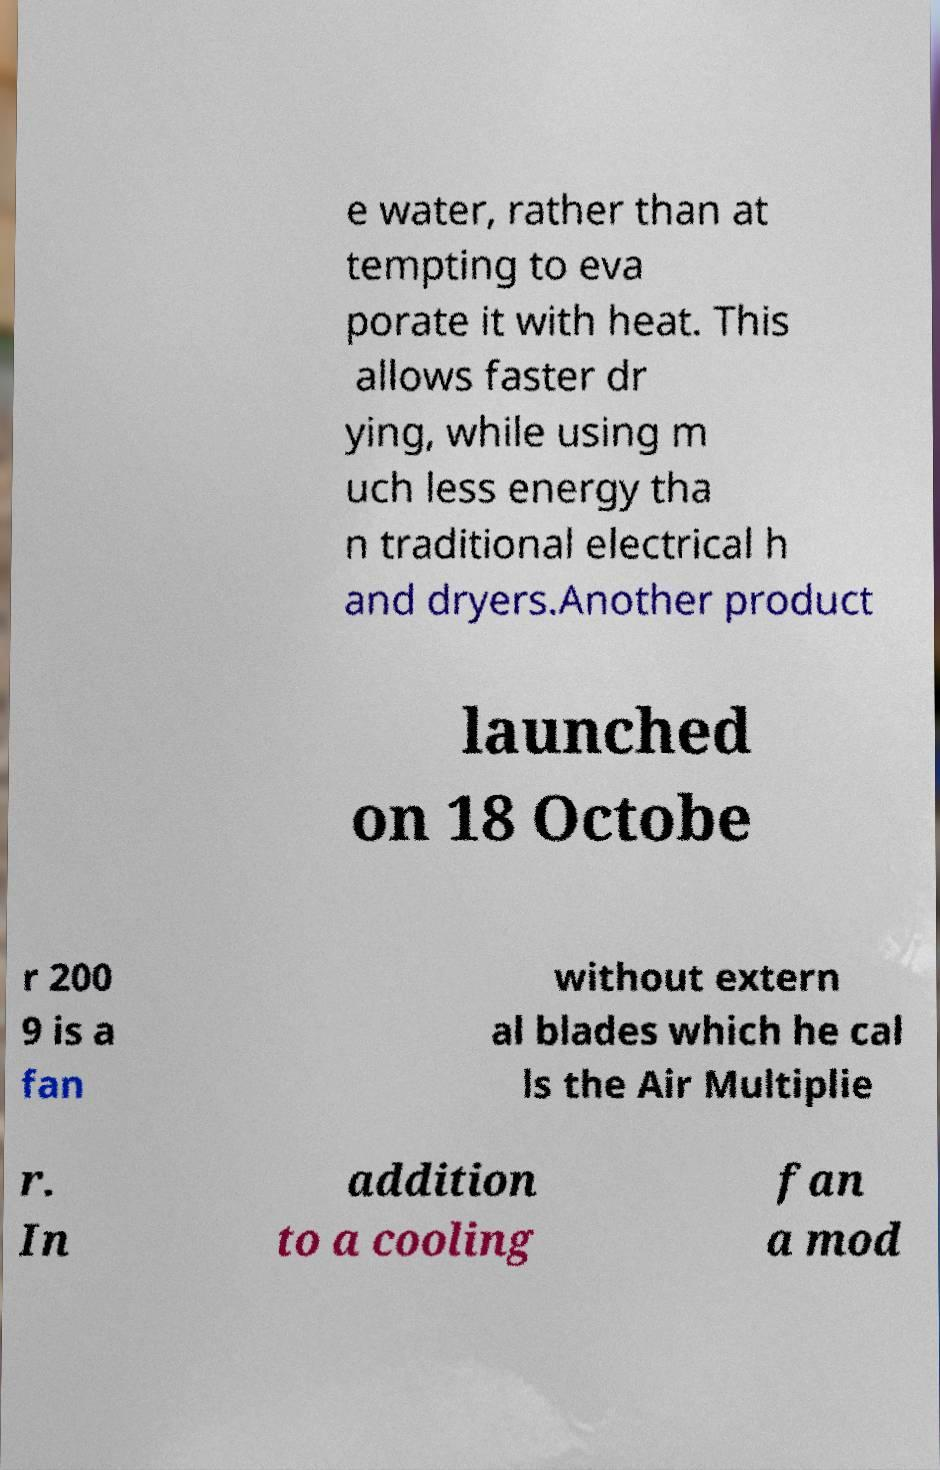Please identify and transcribe the text found in this image. e water, rather than at tempting to eva porate it with heat. This allows faster dr ying, while using m uch less energy tha n traditional electrical h and dryers.Another product launched on 18 Octobe r 200 9 is a fan without extern al blades which he cal ls the Air Multiplie r. In addition to a cooling fan a mod 